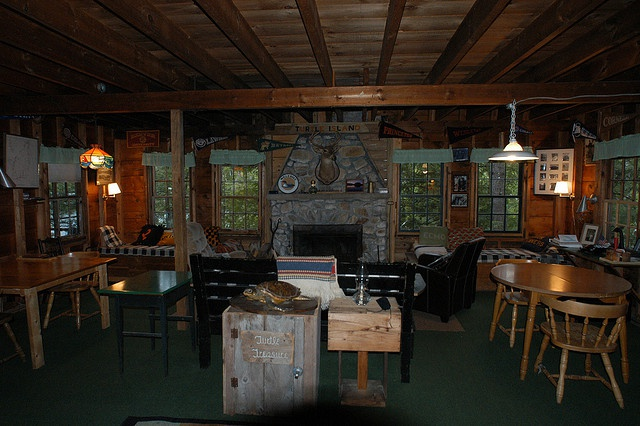Describe the objects in this image and their specific colors. I can see bench in black, gray, darkgray, and purple tones, chair in black, maroon, and gray tones, dining table in black, maroon, and gray tones, chair in black and purple tones, and dining table in black, maroon, and brown tones in this image. 